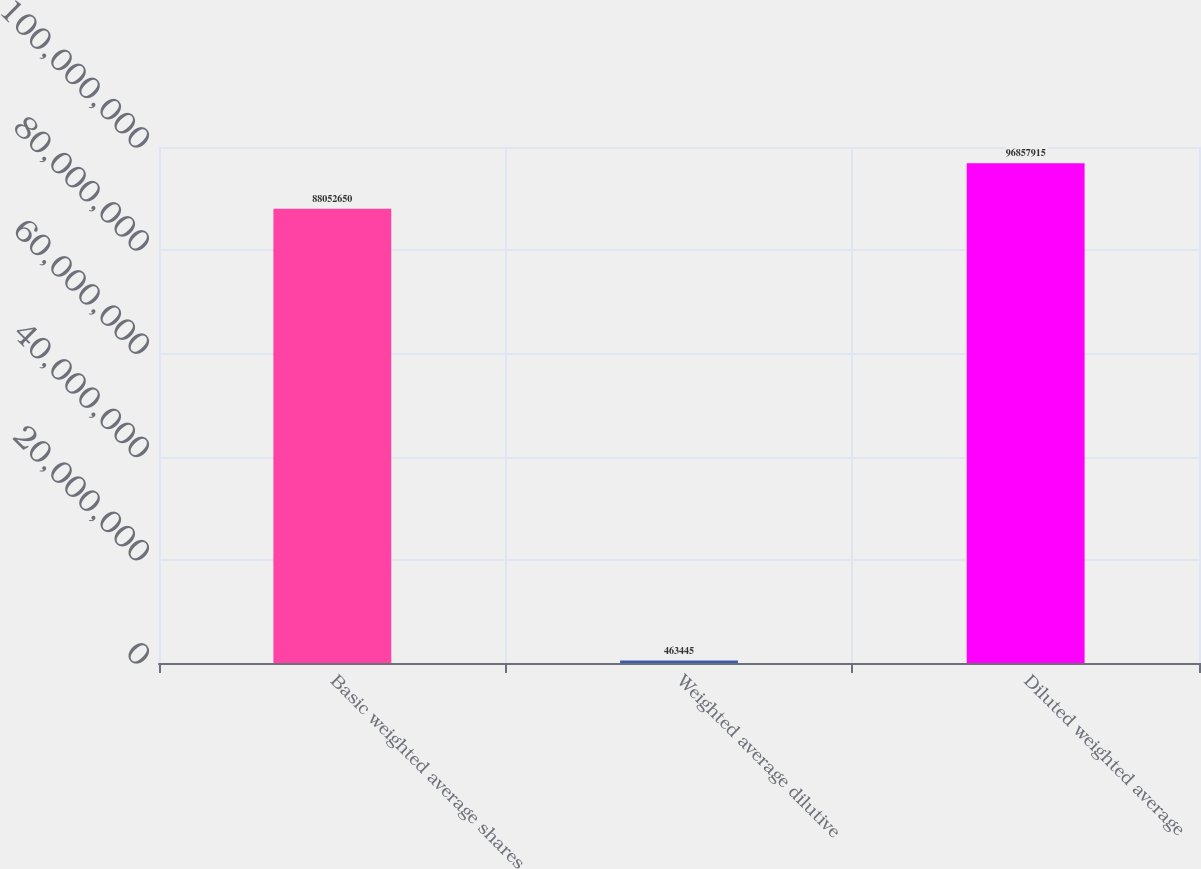Convert chart. <chart><loc_0><loc_0><loc_500><loc_500><bar_chart><fcel>Basic weighted average shares<fcel>Weighted average dilutive<fcel>Diluted weighted average<nl><fcel>8.80526e+07<fcel>463445<fcel>9.68579e+07<nl></chart> 